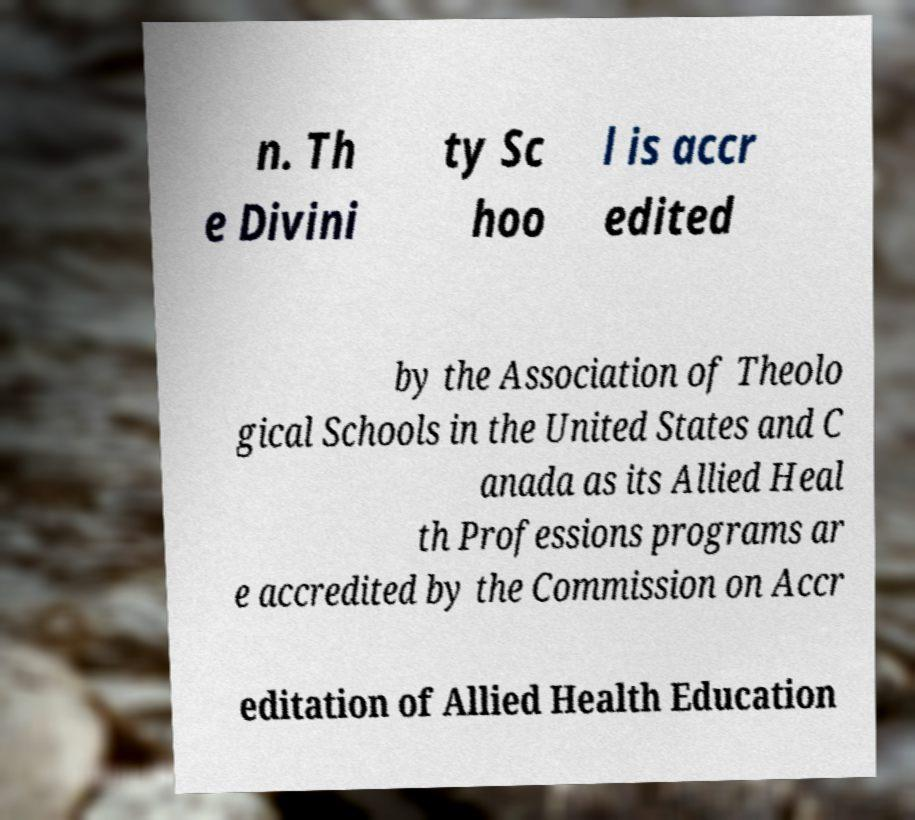Please read and relay the text visible in this image. What does it say? n. Th e Divini ty Sc hoo l is accr edited by the Association of Theolo gical Schools in the United States and C anada as its Allied Heal th Professions programs ar e accredited by the Commission on Accr editation of Allied Health Education 